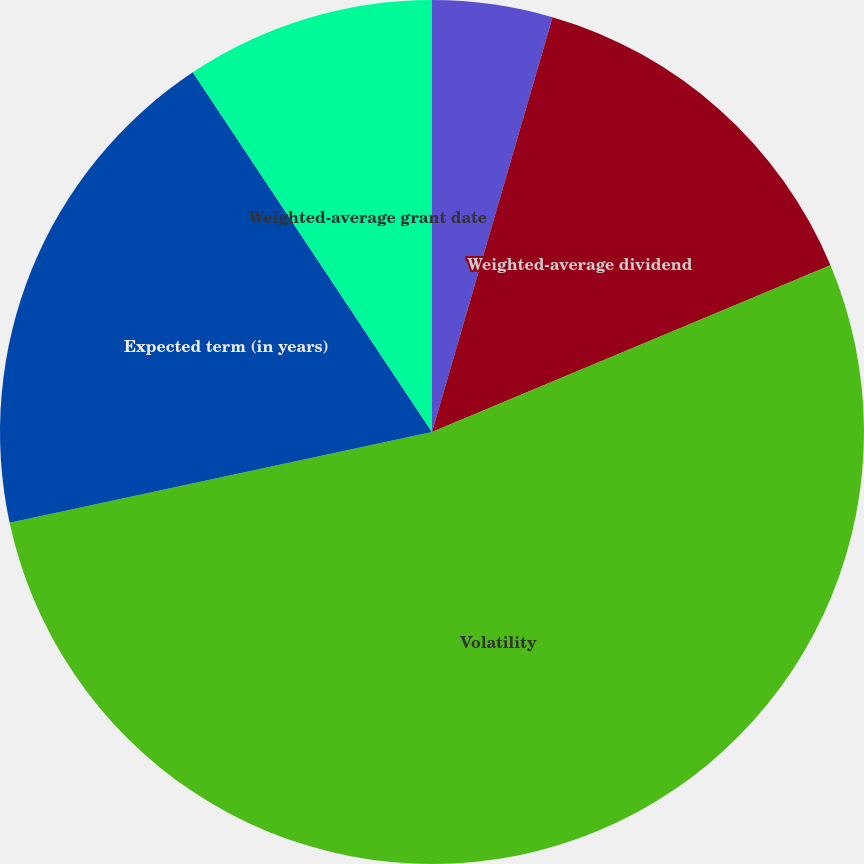Convert chart. <chart><loc_0><loc_0><loc_500><loc_500><pie_chart><fcel>Weighted-average risk-free<fcel>Weighted-average dividend<fcel>Volatility<fcel>Expected term (in years)<fcel>Weighted-average grant date<nl><fcel>4.5%<fcel>14.19%<fcel>52.94%<fcel>19.03%<fcel>9.34%<nl></chart> 